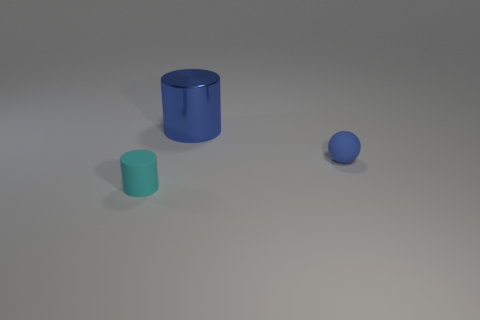Add 1 big cylinders. How many objects exist? 4 Subtract all blue cylinders. How many cylinders are left? 1 Subtract all spheres. How many objects are left? 2 Subtract 2 cylinders. How many cylinders are left? 0 Subtract all red cylinders. Subtract all gray spheres. How many cylinders are left? 2 Subtract all red spheres. How many blue cylinders are left? 1 Subtract all blue cylinders. Subtract all large blue cylinders. How many objects are left? 1 Add 3 small matte objects. How many small matte objects are left? 5 Add 3 large blue objects. How many large blue objects exist? 4 Subtract 0 cyan spheres. How many objects are left? 3 